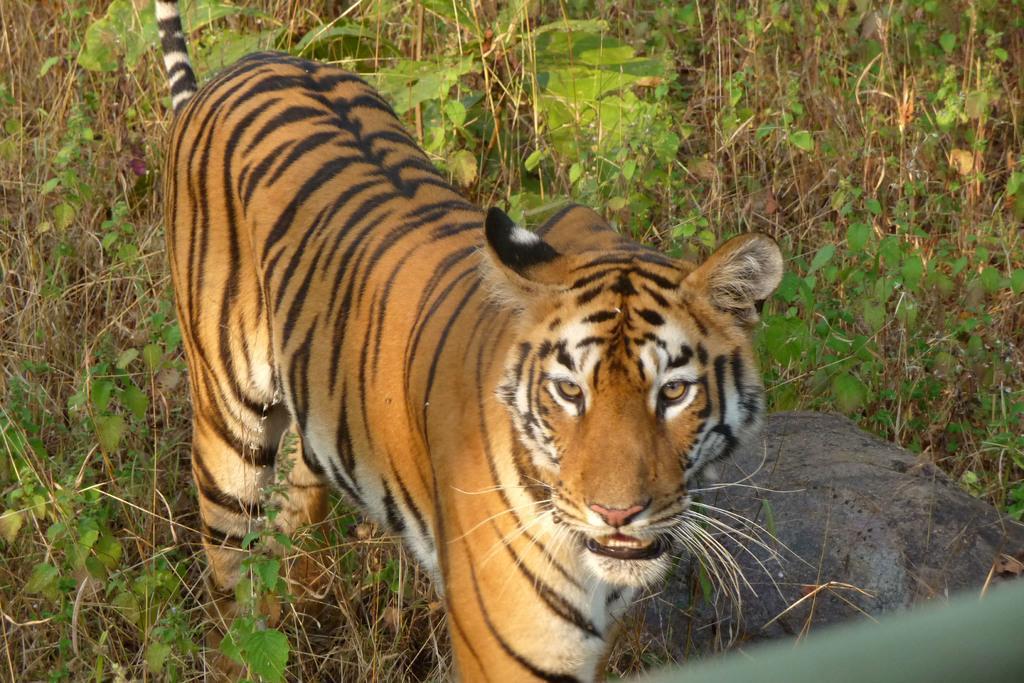How would you summarize this image in a sentence or two? In this image there is a tiger, there are plants, there is a rock towards the right of the image, there is an object towards the bottom of the image. 